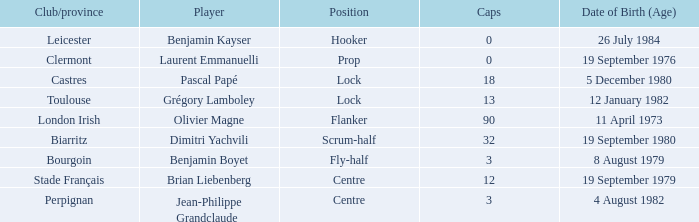Which player has a cap larger than 12 and Clubs of Toulouse? Grégory Lamboley. 